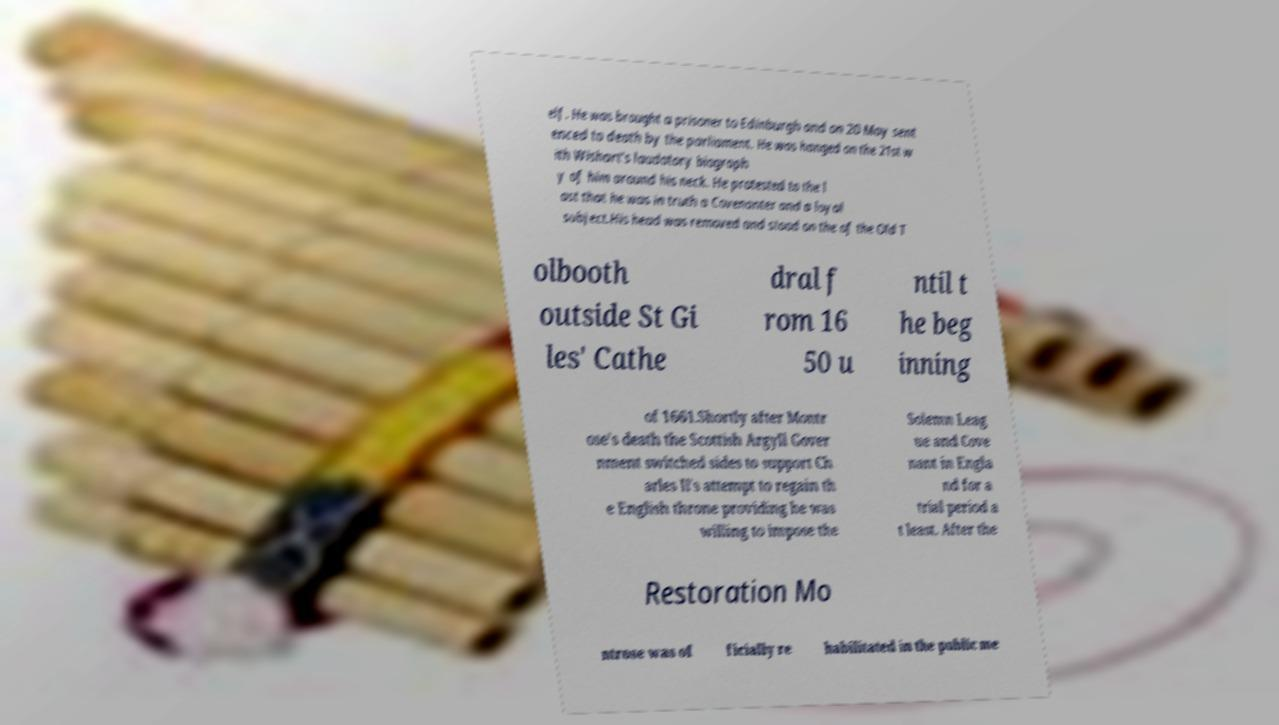What messages or text are displayed in this image? I need them in a readable, typed format. elf. He was brought a prisoner to Edinburgh and on 20 May sent enced to death by the parliament. He was hanged on the 21st w ith Wishart's laudatory biograph y of him around his neck. He protested to the l ast that he was in truth a Covenanter and a loyal subject.His head was removed and stood on the of the Old T olbooth outside St Gi les' Cathe dral f rom 16 50 u ntil t he beg inning of 1661.Shortly after Montr ose's death the Scottish Argyll Gover nment switched sides to support Ch arles II's attempt to regain th e English throne providing he was willing to impose the Solemn Leag ue and Cove nant in Engla nd for a trial period a t least. After the Restoration Mo ntrose was of ficially re habilitated in the public me 